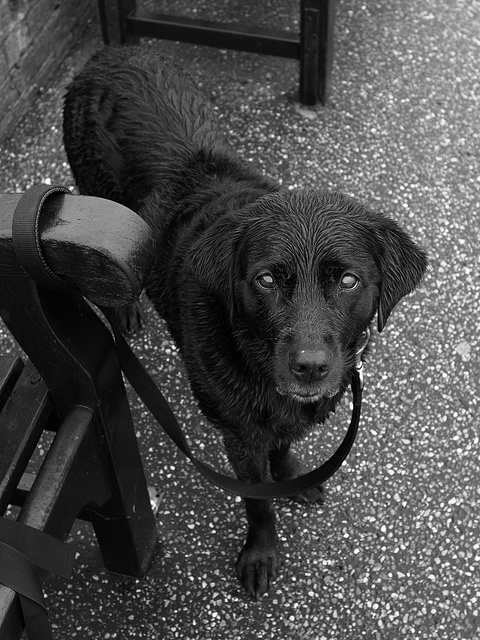Describe the objects in this image and their specific colors. I can see dog in gray, black, and lightgray tones, bench in gray, black, and lightgray tones, and bench in black and gray tones in this image. 